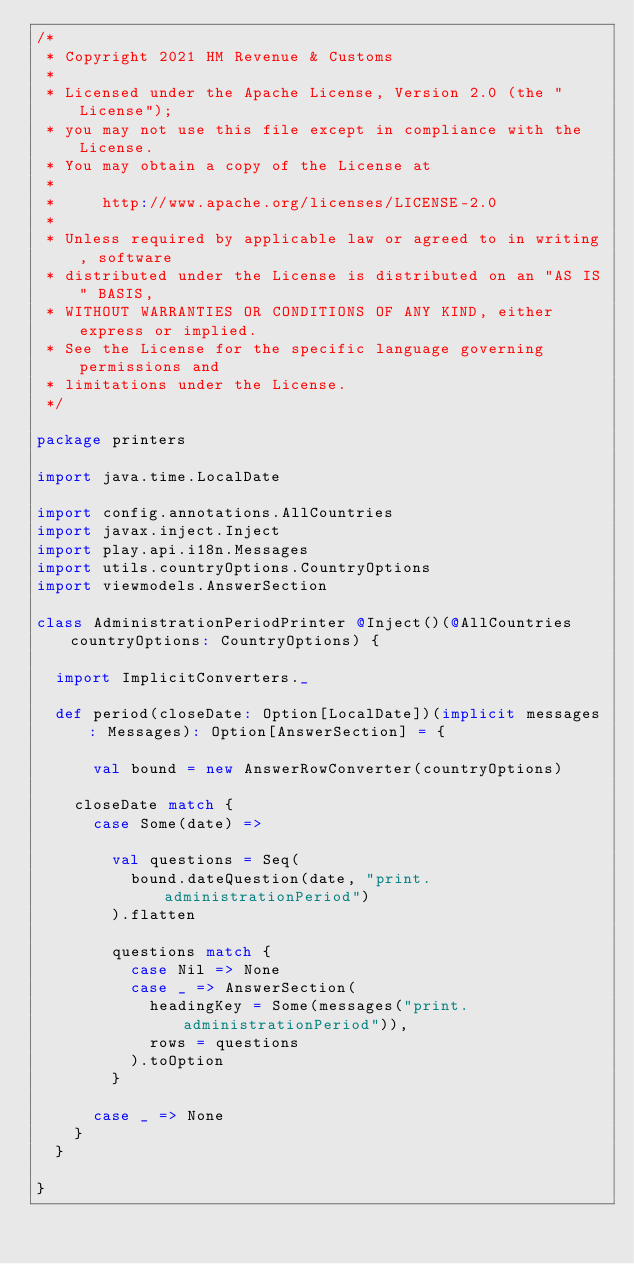Convert code to text. <code><loc_0><loc_0><loc_500><loc_500><_Scala_>/*
 * Copyright 2021 HM Revenue & Customs
 *
 * Licensed under the Apache License, Version 2.0 (the "License");
 * you may not use this file except in compliance with the License.
 * You may obtain a copy of the License at
 *
 *     http://www.apache.org/licenses/LICENSE-2.0
 *
 * Unless required by applicable law or agreed to in writing, software
 * distributed under the License is distributed on an "AS IS" BASIS,
 * WITHOUT WARRANTIES OR CONDITIONS OF ANY KIND, either express or implied.
 * See the License for the specific language governing permissions and
 * limitations under the License.
 */

package printers

import java.time.LocalDate

import config.annotations.AllCountries
import javax.inject.Inject
import play.api.i18n.Messages
import utils.countryOptions.CountryOptions
import viewmodels.AnswerSection

class AdministrationPeriodPrinter @Inject()(@AllCountries countryOptions: CountryOptions) {

  import ImplicitConverters._

  def period(closeDate: Option[LocalDate])(implicit messages: Messages): Option[AnswerSection] = {

      val bound = new AnswerRowConverter(countryOptions)

    closeDate match {
      case Some(date) =>

        val questions = Seq(
          bound.dateQuestion(date, "print.administrationPeriod")
        ).flatten

        questions match {
          case Nil => None
          case _ => AnswerSection(
            headingKey = Some(messages("print.administrationPeriod")),
            rows = questions
          ).toOption
        }

      case _ => None
    }
  }

}
</code> 